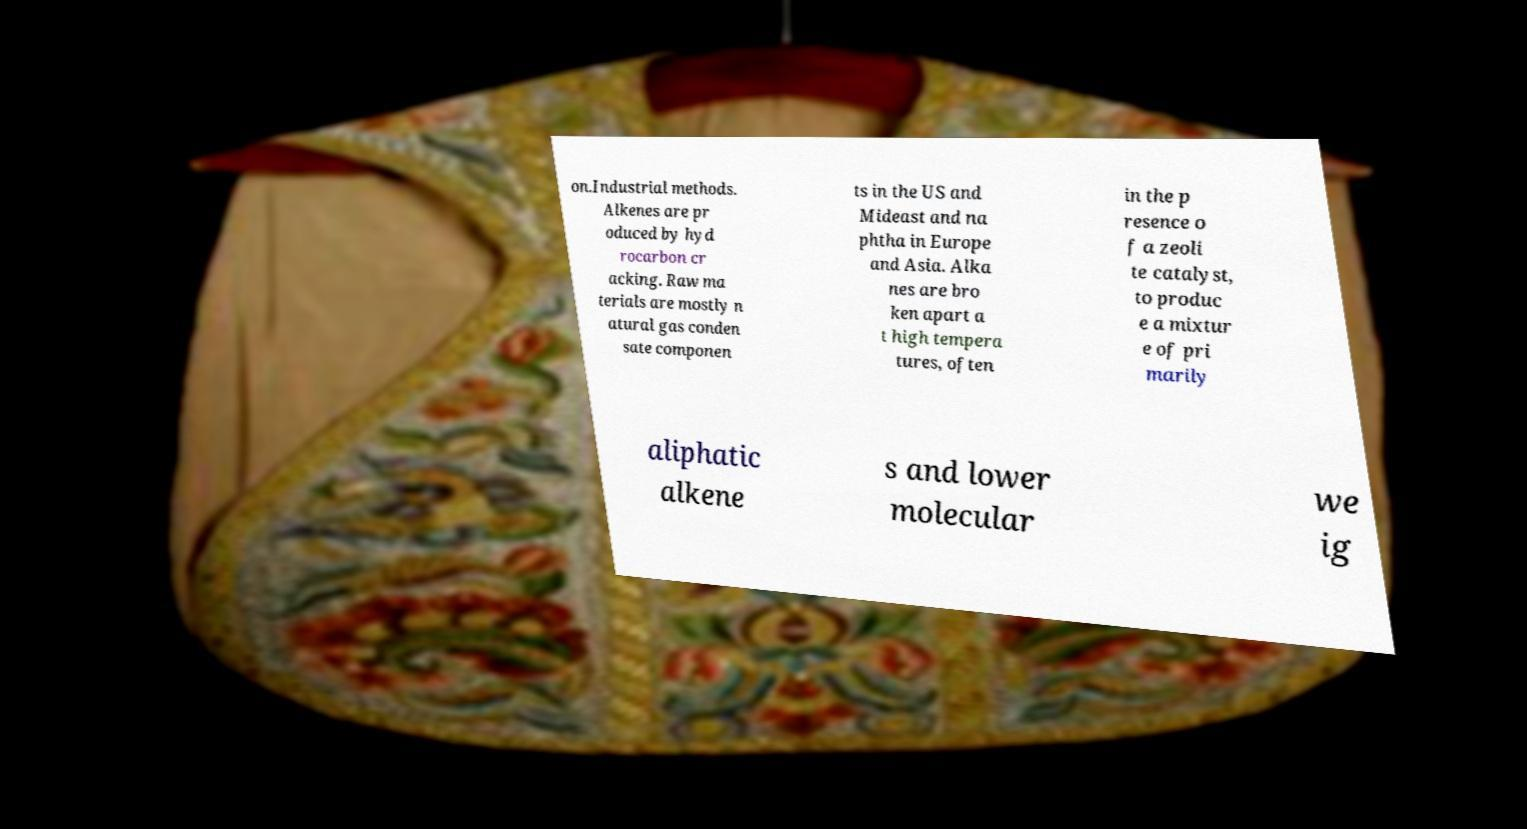I need the written content from this picture converted into text. Can you do that? on.Industrial methods. Alkenes are pr oduced by hyd rocarbon cr acking. Raw ma terials are mostly n atural gas conden sate componen ts in the US and Mideast and na phtha in Europe and Asia. Alka nes are bro ken apart a t high tempera tures, often in the p resence o f a zeoli te catalyst, to produc e a mixtur e of pri marily aliphatic alkene s and lower molecular we ig 